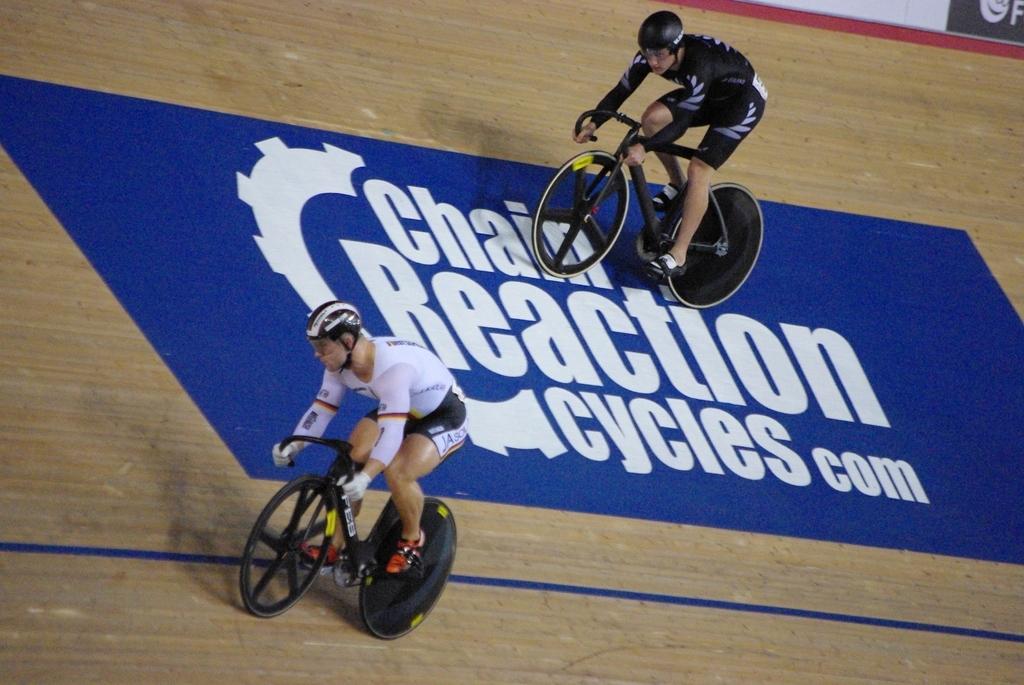<image>
Relay a brief, clear account of the picture shown. An ad for chain Reaction Cycles is on a blue area of a floor. 